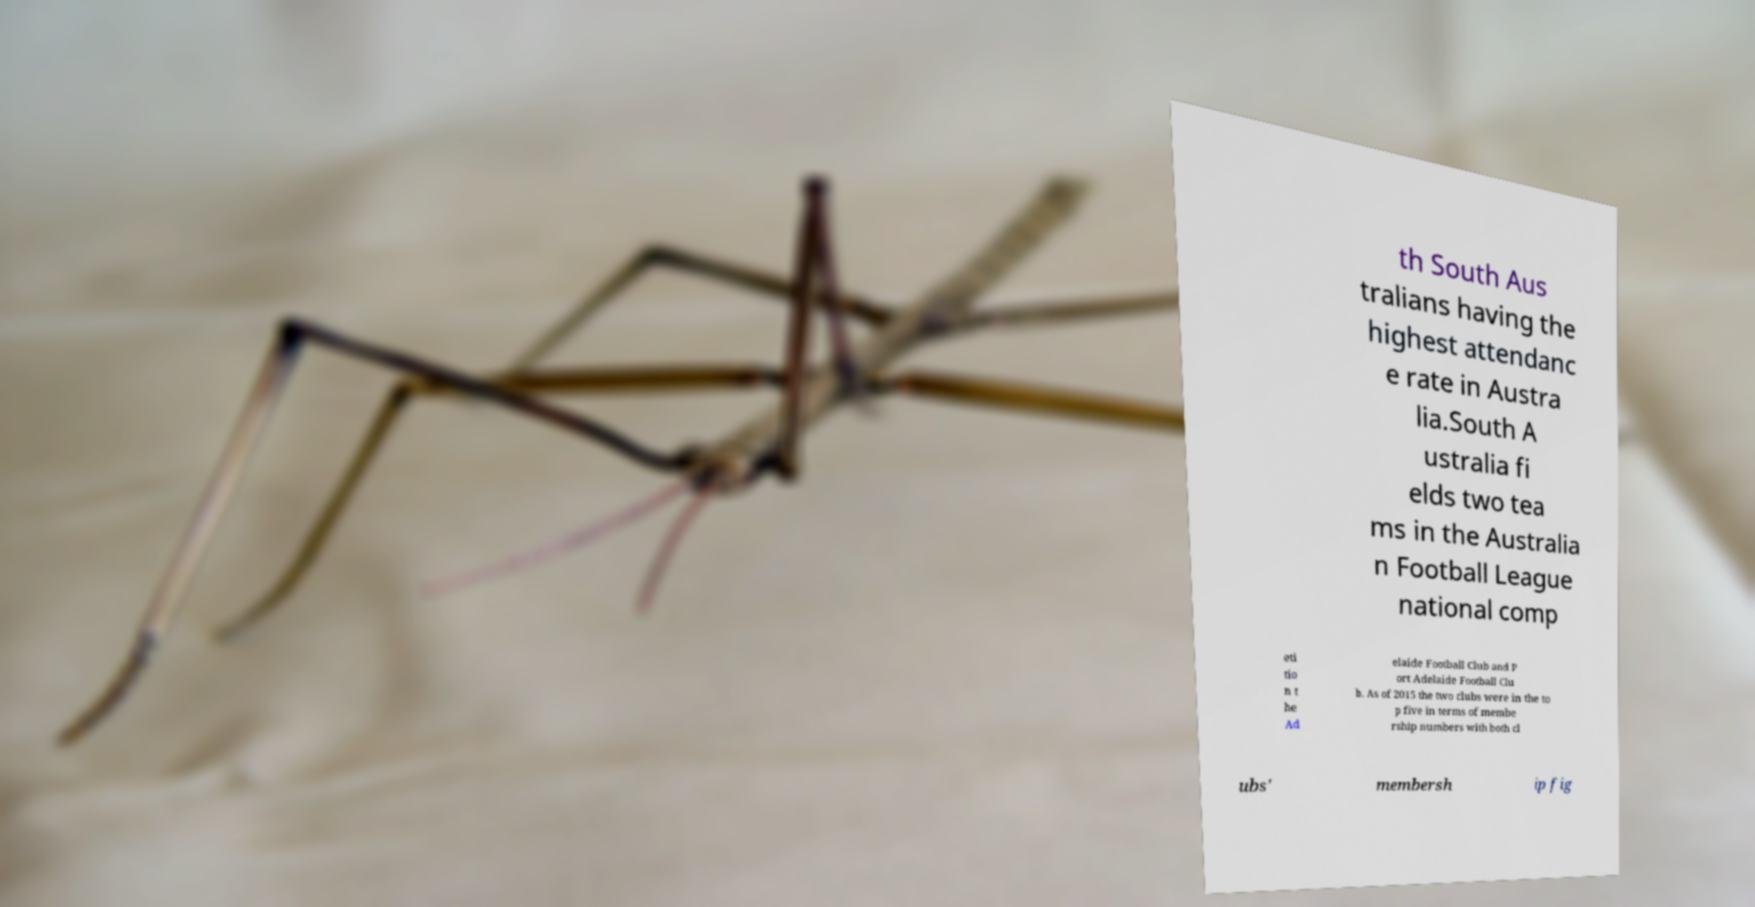There's text embedded in this image that I need extracted. Can you transcribe it verbatim? th South Aus tralians having the highest attendanc e rate in Austra lia.South A ustralia fi elds two tea ms in the Australia n Football League national comp eti tio n t he Ad elaide Football Club and P ort Adelaide Football Clu b. As of 2015 the two clubs were in the to p five in terms of membe rship numbers with both cl ubs' membersh ip fig 